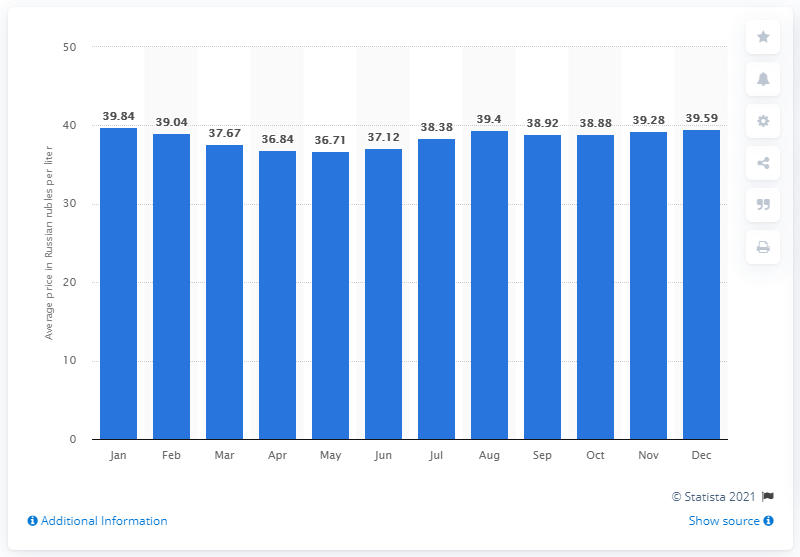Highlight a few significant elements in this photo. The highest retail price of bottled water in Russia in January was 39.84 rubles. In May, the lowest price of bottled water was 36.71 dollars per bottle. 